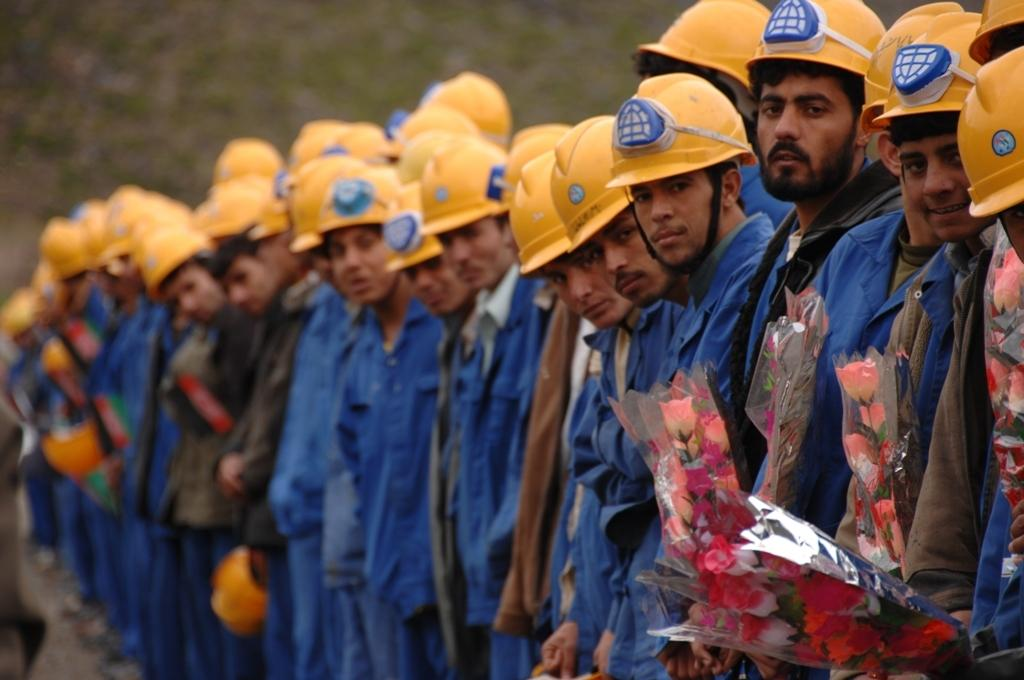What type of people can be seen in the image? There are workers in the image. What are the workers wearing on their upper bodies? The workers are wearing blue shirts. What protective gear are the workers wearing? The workers are wearing helmets. How are the workers positioned in relation to each other? The workers are standing side by side. Can you see a yak in the image? No, there is no yak present in the image. What type of bird is perched on the shoulder of one of the workers? There is no bird, such as a wren, present in the image. 